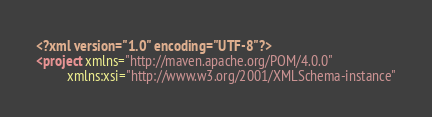<code> <loc_0><loc_0><loc_500><loc_500><_XML_><?xml version="1.0" encoding="UTF-8"?>
<project xmlns="http://maven.apache.org/POM/4.0.0"
         xmlns:xsi="http://www.w3.org/2001/XMLSchema-instance"</code> 